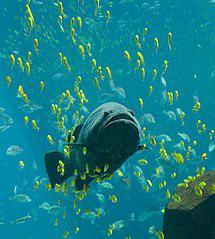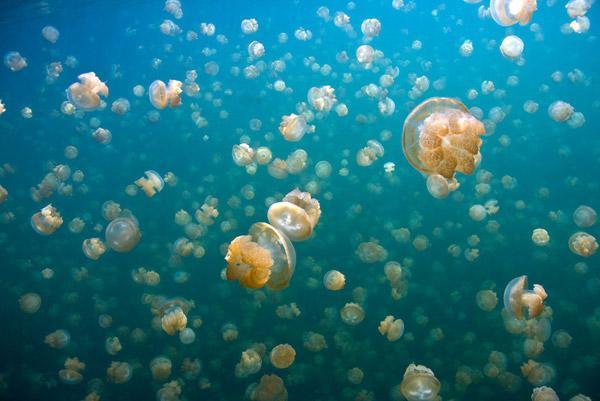The first image is the image on the left, the second image is the image on the right. For the images shown, is this caption "The rippled surface of the water is visible in one of the images." true? Answer yes or no. No. 